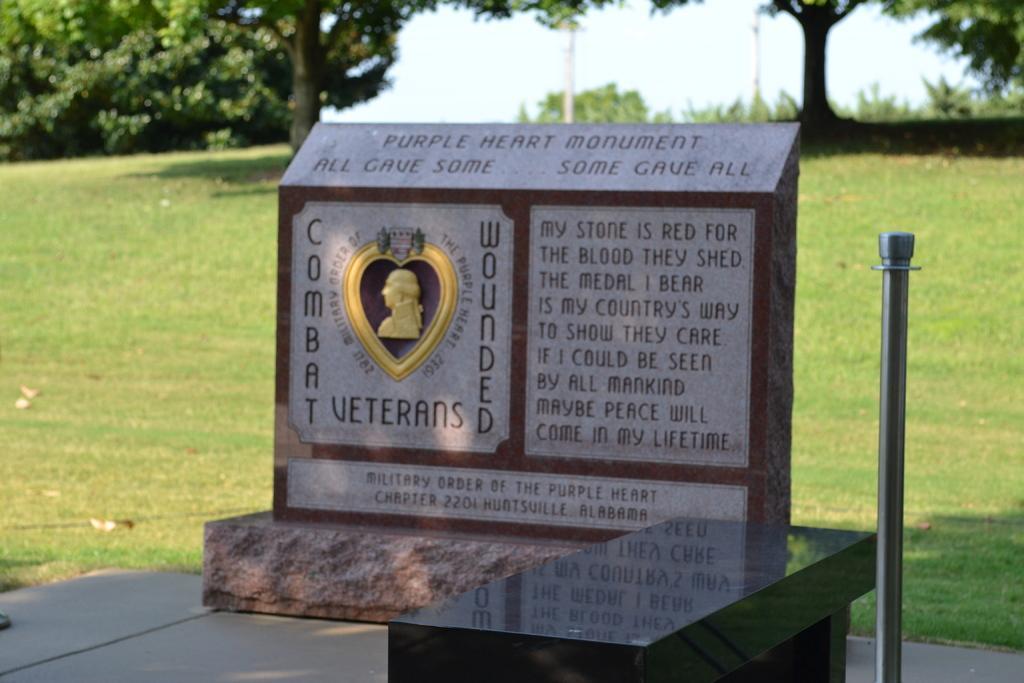Describe this image in one or two sentences. In this picture we can see a memorial, beside to the memorial we can find a metal rod, in the background we can see grass, fed poles and trees. 